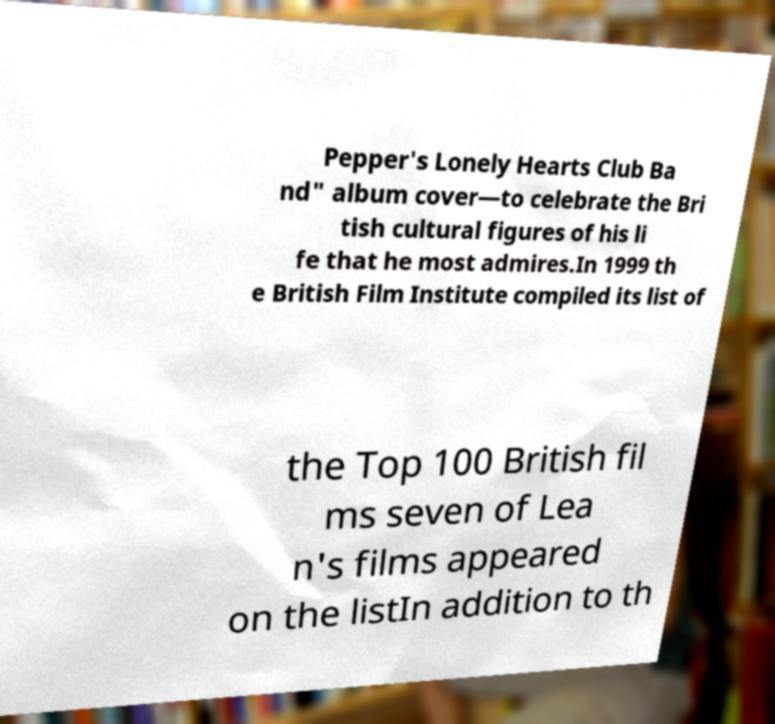What messages or text are displayed in this image? I need them in a readable, typed format. Pepper's Lonely Hearts Club Ba nd" album cover—to celebrate the Bri tish cultural figures of his li fe that he most admires.In 1999 th e British Film Institute compiled its list of the Top 100 British fil ms seven of Lea n's films appeared on the listIn addition to th 